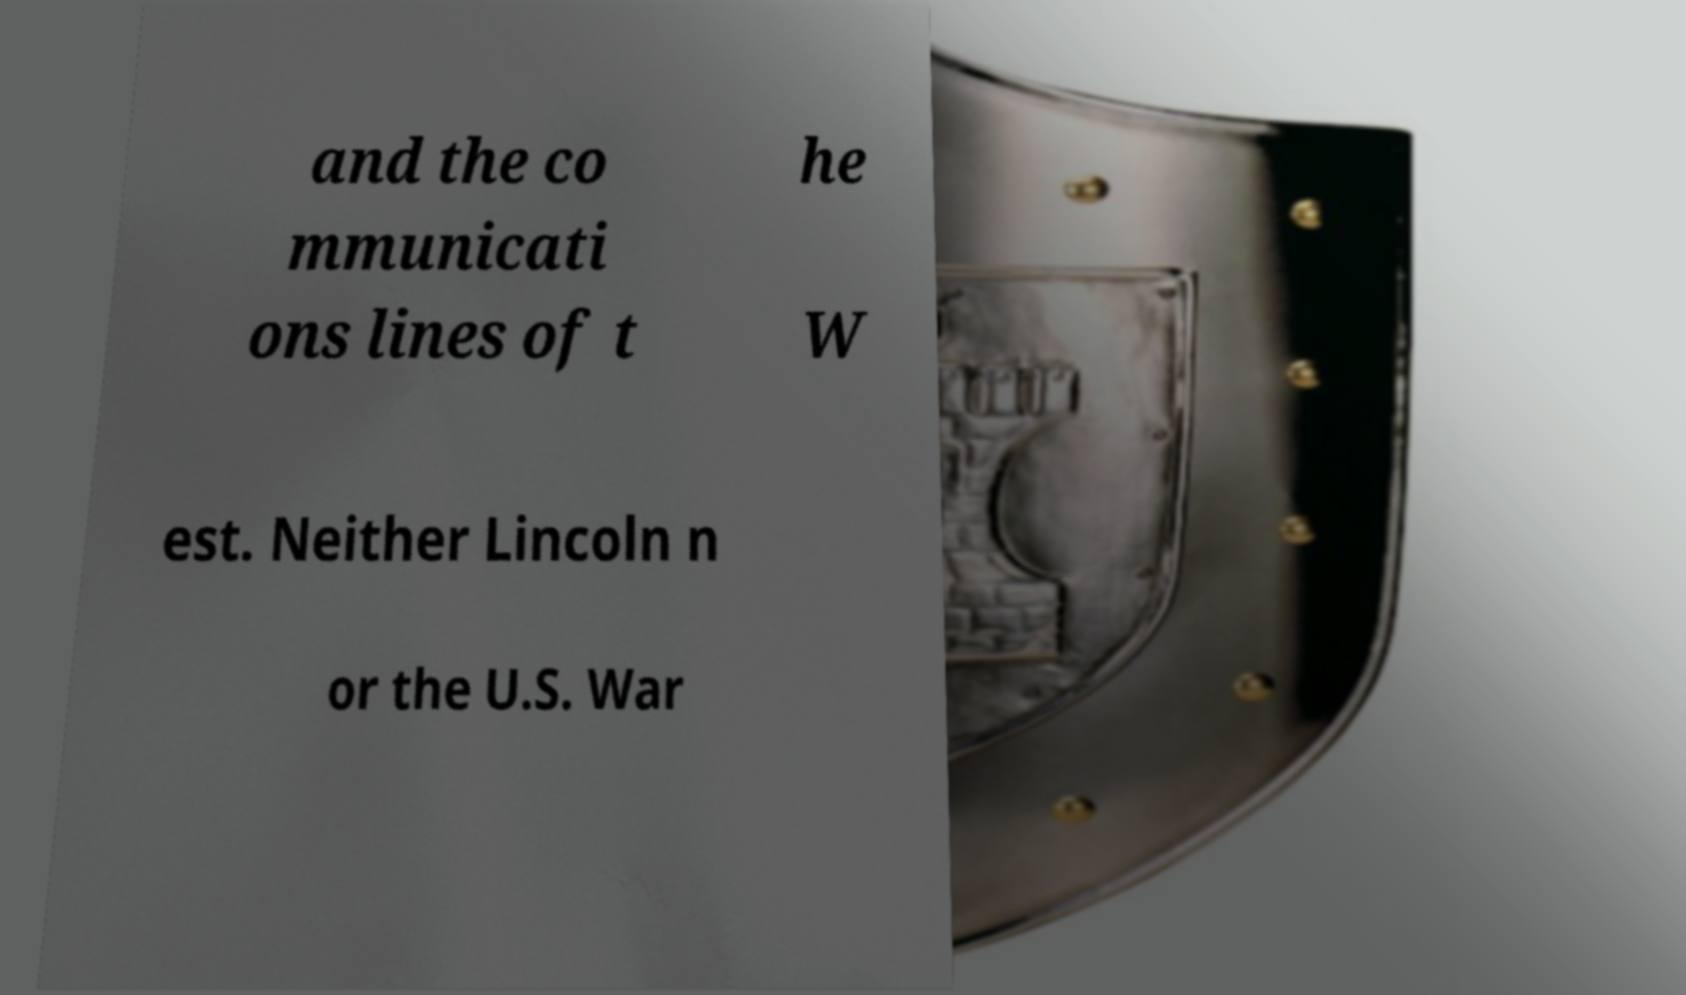Please identify and transcribe the text found in this image. and the co mmunicati ons lines of t he W est. Neither Lincoln n or the U.S. War 